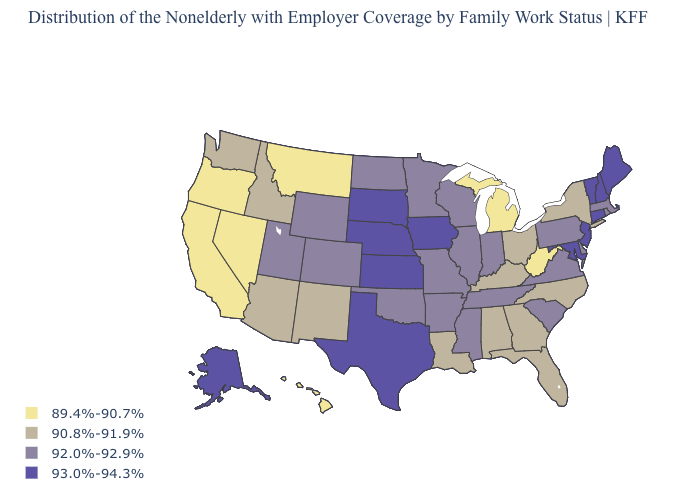What is the value of Alabama?
Give a very brief answer. 90.8%-91.9%. How many symbols are there in the legend?
Write a very short answer. 4. What is the value of Washington?
Give a very brief answer. 90.8%-91.9%. Which states have the lowest value in the MidWest?
Write a very short answer. Michigan. Among the states that border Ohio , which have the highest value?
Short answer required. Indiana, Pennsylvania. Does California have the lowest value in the West?
Be succinct. Yes. How many symbols are there in the legend?
Short answer required. 4. What is the value of South Carolina?
Keep it brief. 92.0%-92.9%. What is the value of North Carolina?
Keep it brief. 90.8%-91.9%. Does Connecticut have a higher value than Vermont?
Short answer required. No. Name the states that have a value in the range 89.4%-90.7%?
Write a very short answer. California, Hawaii, Michigan, Montana, Nevada, Oregon, West Virginia. Which states have the lowest value in the USA?
Be succinct. California, Hawaii, Michigan, Montana, Nevada, Oregon, West Virginia. Does the first symbol in the legend represent the smallest category?
Short answer required. Yes. What is the value of Nebraska?
Concise answer only. 93.0%-94.3%. What is the value of Missouri?
Be succinct. 92.0%-92.9%. 